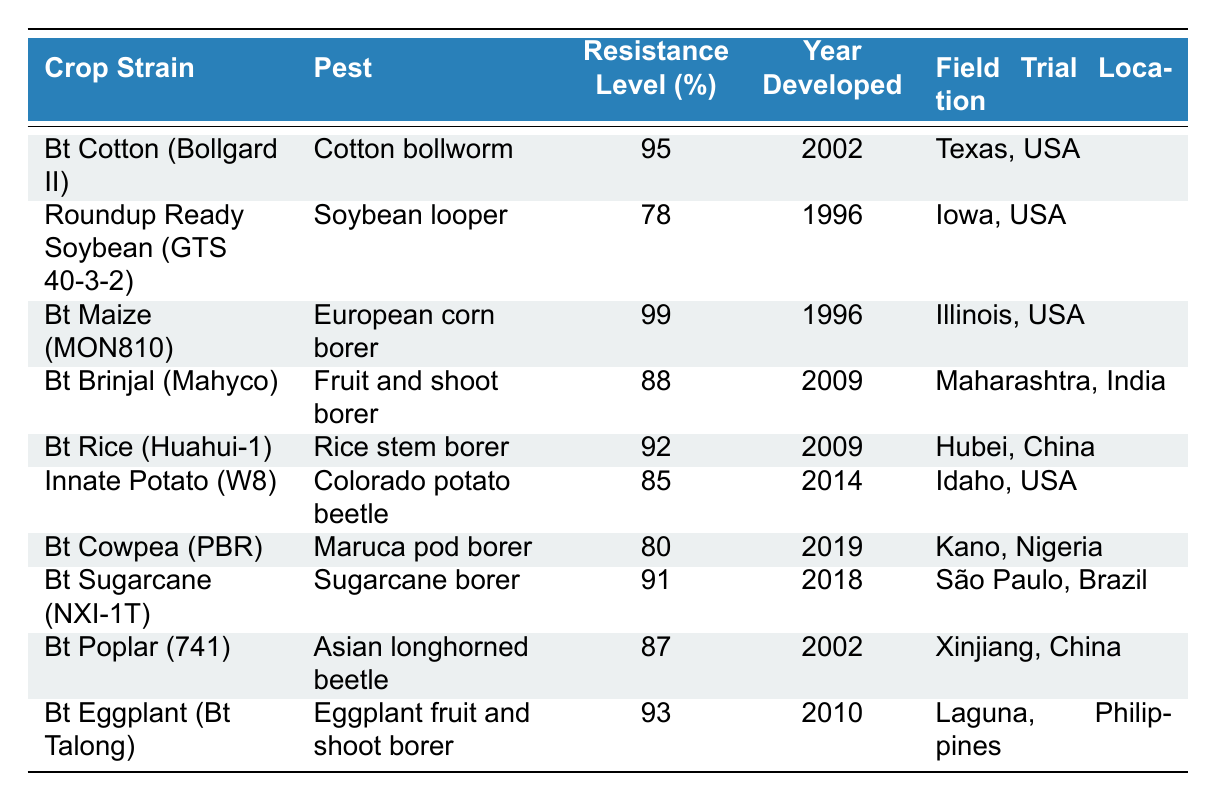What is the resistance level of Bt Maize (MON810)? The table shows that for the crop strain Bt Maize (MON810), the resistance level is listed as 99%.
Answer: 99% Which crop strain has the highest resistance level? By examining the resistance levels in the table, Bt Maize (MON810) has the highest resistance level at 99%.
Answer: Bt Maize (MON810) What pest is Bt Cotton (Bollgard II) resistant to? The table indicates that Bt Cotton (Bollgard II) is resistant to the Cotton bollworm.
Answer: Cotton bollworm How many crop strains were developed after 2000? The data points developed after 2000 include Bt Brinjal (2009), Bt Rice (2009), Innate Potato (2014), Bt Cowpea (2019), and Bt Sugarcane (2018), totaling five strains.
Answer: 5 What is the average resistance level of all the crop strains listed? Adding the resistance levels together: (95 + 78 + 99 + 88 + 92 + 85 + 80 + 91 + 87 + 93) = 918, and dividing by 10 gives an average of 91.8.
Answer: 91.8 Is Bt Sugarcane (NXI-1T) more resistant to pests than Innate Potato (W8)? Bt Sugarcane has a resistance level of 91%, while Innate Potato has a resistance level of 85%, which means Bt Sugarcane is more resistant.
Answer: Yes Which field trial location is associated with the development of Bt Cowpea (PBR)? The table states that the field trial location for Bt Cowpea (PBR) is Kano, Nigeria.
Answer: Kano, Nigeria How many crop strains mentioned on the table are developed in the USA? The table lists Bt Cotton (Texas), Roundup Ready Soybean (Iowa), Innate Potato (Idaho), and Bt Sugarcane (São Paulo, Brazil), totaling four strains developed in the USA specifically.
Answer: 3 What is the difference in resistance levels between Bt Brinjal (Mahyco) and Bt Rice (Huahui-1)? The resistance level of Bt Brinjal is 88% while Bt Rice has 92%, so the difference is 92% - 88% = 4%.
Answer: 4% Which crop strains were developed in 2009? The table indicates that both Bt Brinjal (Mahyco) and Bt Rice (Huahui-1) were developed in 2009.
Answer: Bt Brinjal (Mahyco), Bt Rice (Huahui-1) 